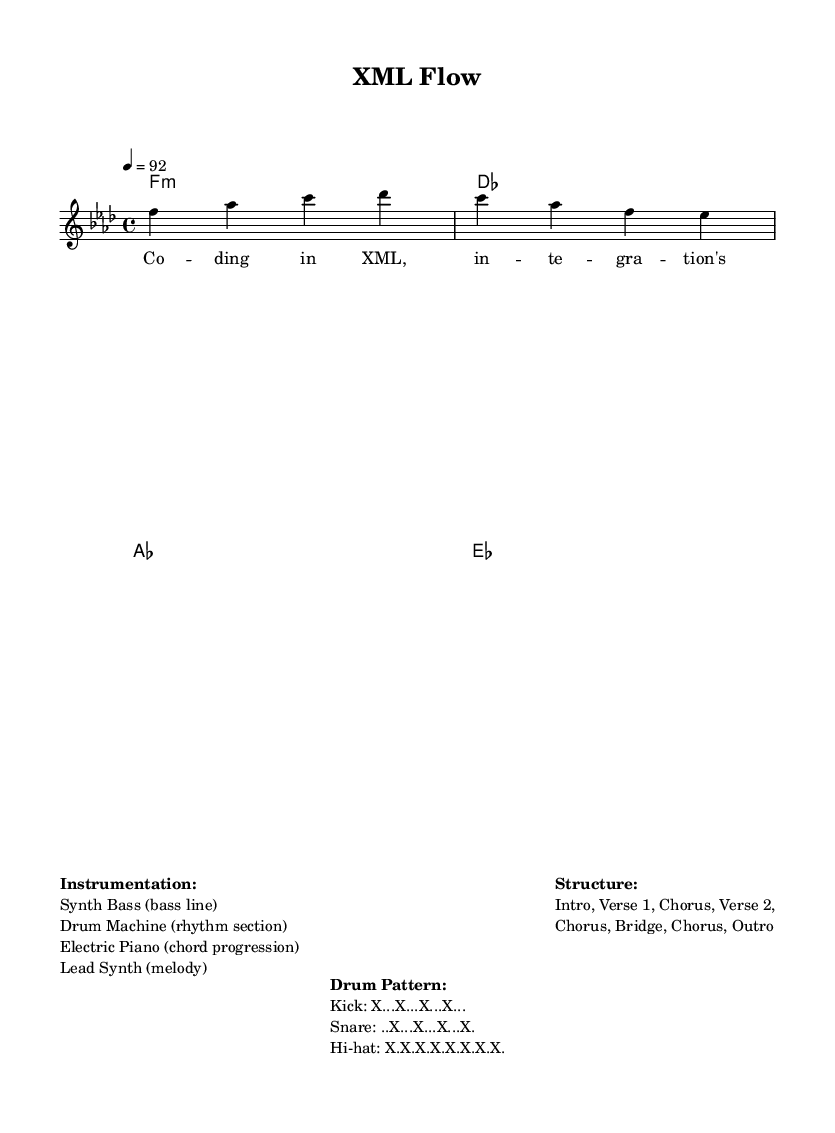What is the key signature of this music? The key signature is F minor, which is indicated by four flats (B♭, E♭, A♭, and D♭).
Answer: F minor What is the time signature of this music? The time signature is 4/4, which means there are four beats in each measure and a quarter note receives one beat.
Answer: 4/4 What is the tempo of this piece? The tempo marking indicates that the piece is to be played at 92 beats per minute.
Answer: 92 What are the instruments used in this track? The instrumentation includes a Synth Bass for the bass line, a Drum Machine for the rhythm section, an Electric Piano for the chord progression, and a Lead Synth for the melody.
Answer: Synth Bass, Drum Machine, Electric Piano, Lead Synth Which section comes after the first verse? The structure of the piece shows that after the first verse, the chorus follows.
Answer: Chorus What is the drum pattern for the kick? The drum pattern for the kick is represented as 'X...X...X...X...', meaning there is a kick on every beat of the measure.
Answer: X...X...X...X.. How does the lyrical theme connect to the music's structure? The lyrics emphasize coding in XML, directly linking the technical theme of software development to the song's overall structure, indicating a cohesive message throughout all sections.
Answer: Cohesive message 